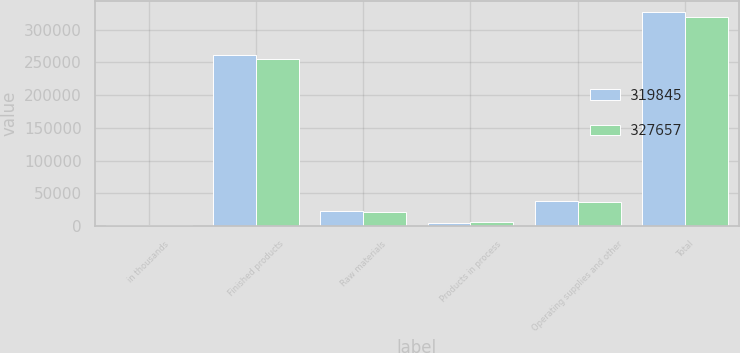Convert chart to OTSL. <chart><loc_0><loc_0><loc_500><loc_500><stacked_bar_chart><ecel><fcel>in thousands<fcel>Finished products<fcel>Raw materials<fcel>Products in process<fcel>Operating supplies and other<fcel>Total<nl><fcel>319845<fcel>2011<fcel>260732<fcel>23819<fcel>4198<fcel>38908<fcel>327657<nl><fcel>327657<fcel>2010<fcel>254840<fcel>22222<fcel>6036<fcel>36747<fcel>319845<nl></chart> 